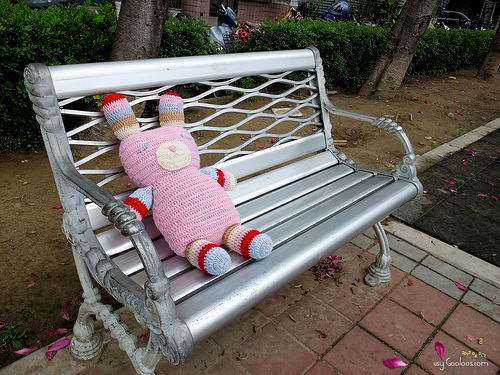<image>
Is there a doll on the chair? Yes. Looking at the image, I can see the doll is positioned on top of the chair, with the chair providing support. Is the stuffed rabbit on the silver bench? Yes. Looking at the image, I can see the stuffed rabbit is positioned on top of the silver bench, with the silver bench providing support. Is there a stuffed animal to the left of the bench? No. The stuffed animal is not to the left of the bench. From this viewpoint, they have a different horizontal relationship. 